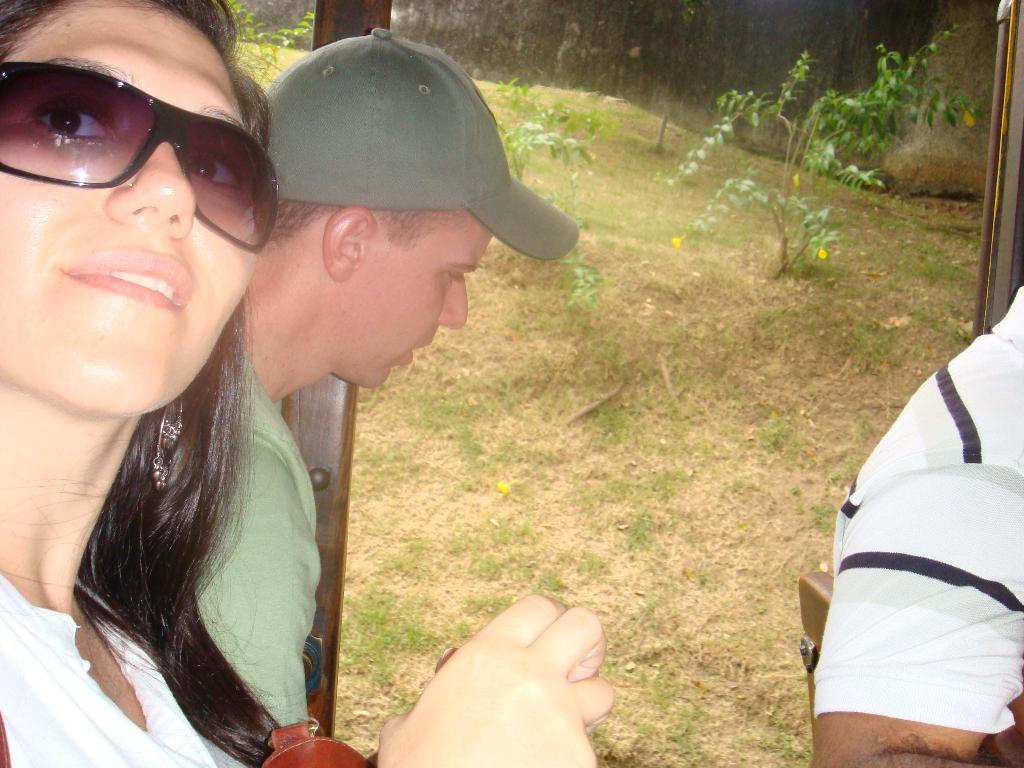How would you summarize this image in a sentence or two? In the picture we can see a man and a woman sitting together, woman is in white dress and goggles and man is in green T-shirt and beside them we can see grass surface with some plants and behind it we can see some plants which are not clearly visible. 